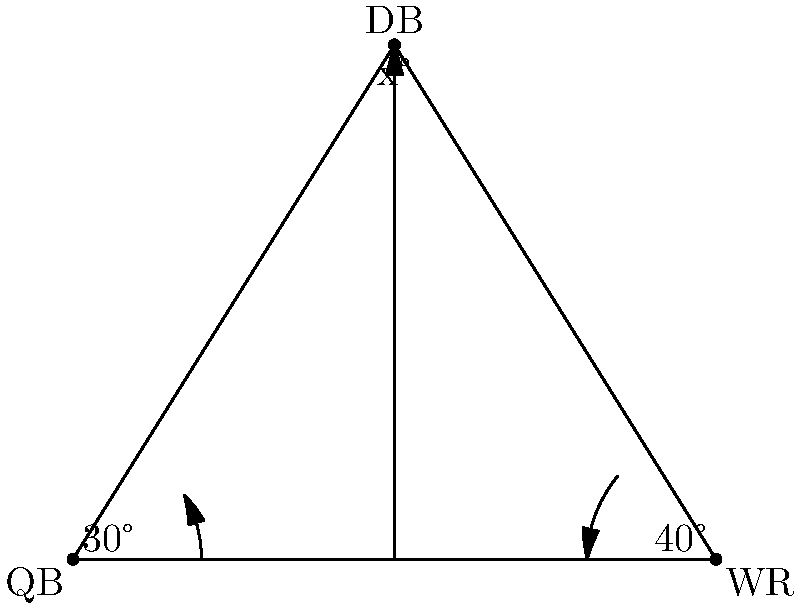In the diagram, a quarterback (QB) and wide receiver (WR) are positioned at opposite ends of the line of scrimmage. A defensive back (DB) is positioned downfield. The angle between the QB and the DB's path is 30°, while the angle between the WR and the DB's path is 40°. What is the angle $x$ at which the DB should intercept the ball? To solve this problem, we'll use the properties of triangles:

1) In any triangle, the sum of all angles is 180°.

2) We can see that the triangle formed by QB, WR, and DB has all its angles:
   - Angle at QB = 30°
   - Angle at WR = 40°
   - Angle at DB = $x°$ (which we need to find)

3) Using the triangle angle sum theorem:
   $30° + 40° + x° = 180°$

4) Simplify:
   $70° + x° = 180°$

5) Subtract 70° from both sides:
   $x° = 180° - 70°$

6) Calculate:
   $x° = 110°$

Therefore, the angle at which the DB should intercept the ball is 110°.
Answer: $110°$ 